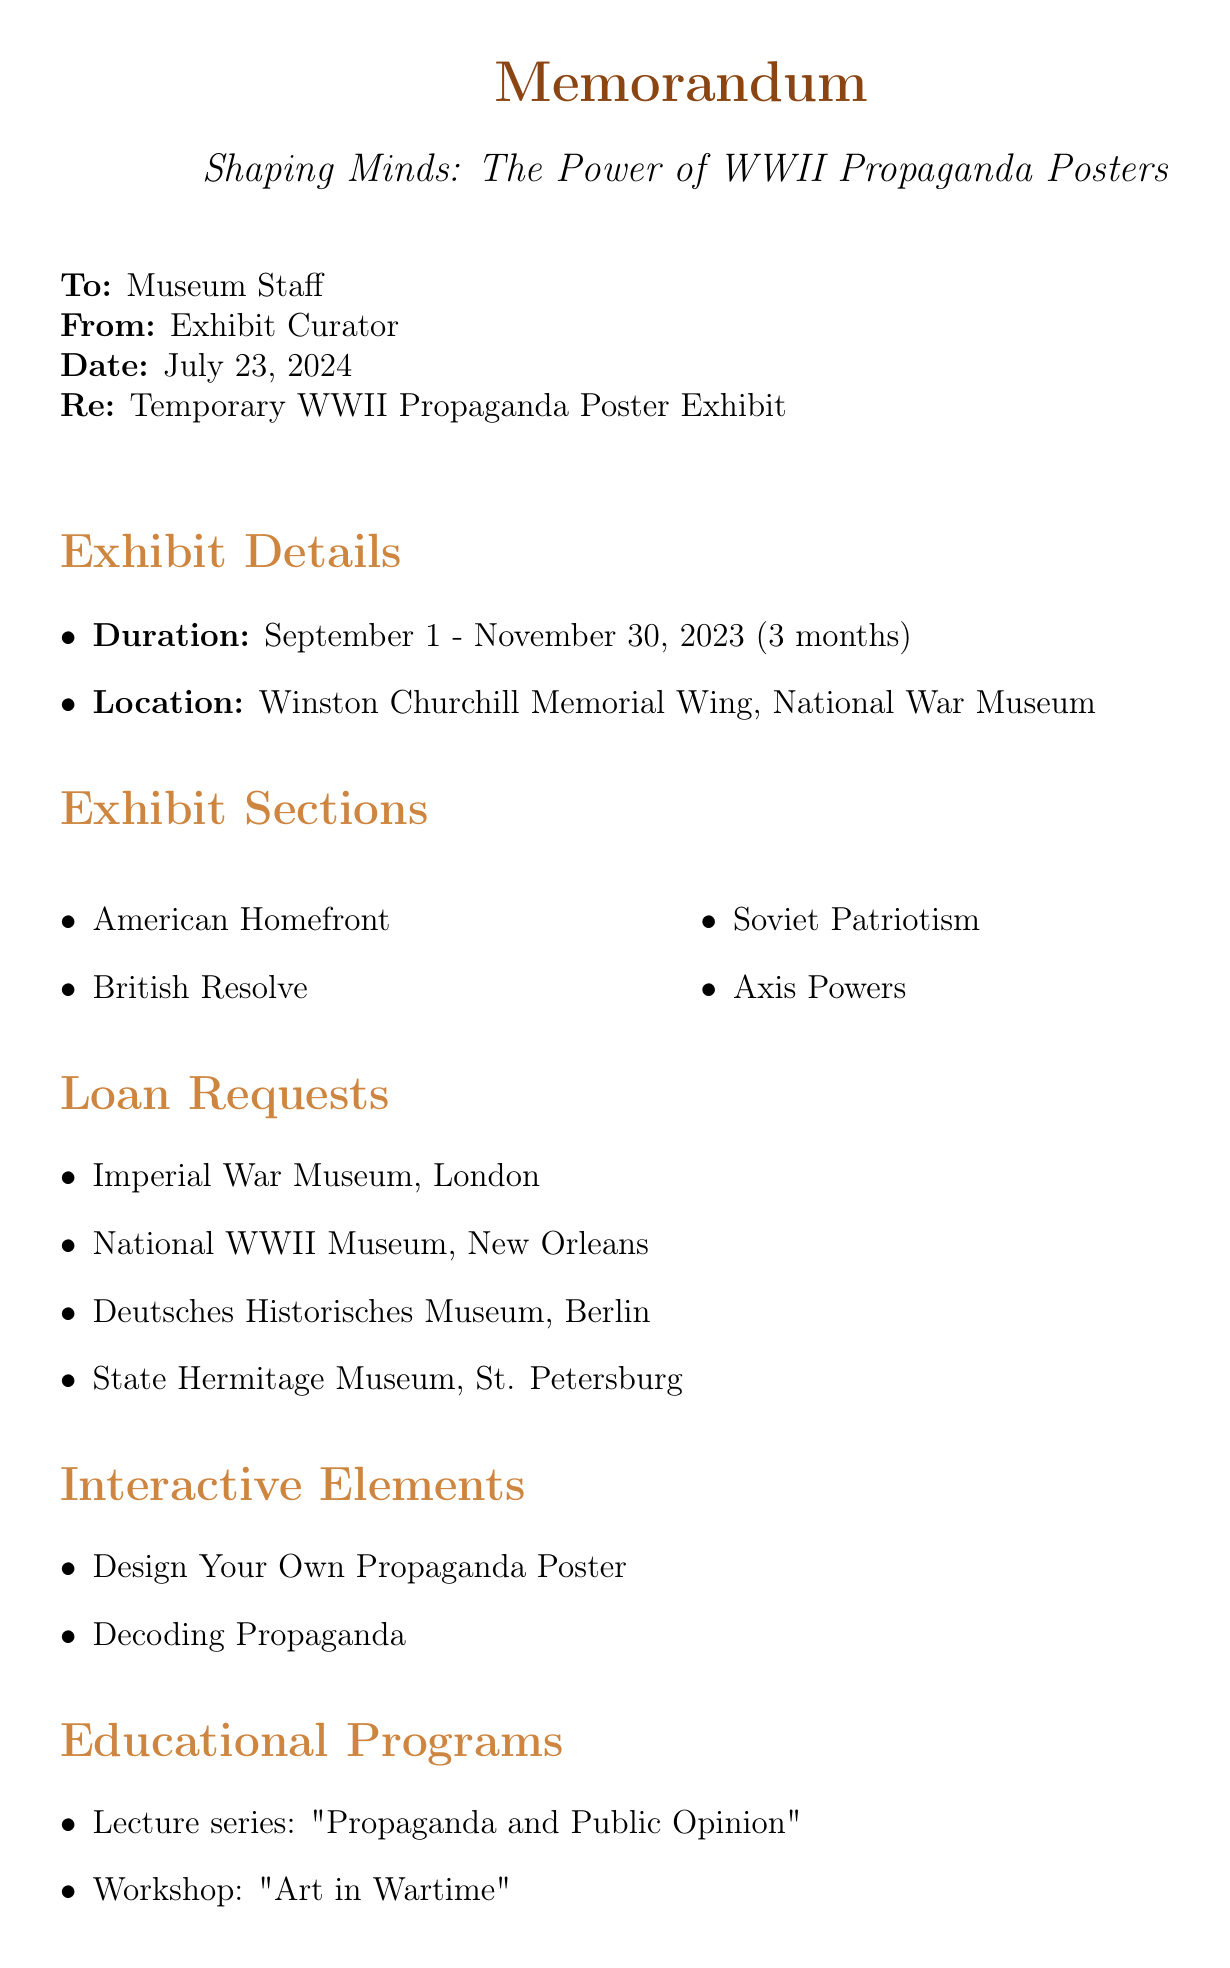What is the title of the exhibit? The title of the exhibit is stated at the beginning of the document.
Answer: Shaping Minds: The Power of WWII Propaganda Posters What is the duration of the exhibit? The duration is specified in the exhibit details.
Answer: 3 months (September 1 - November 30, 2023) Where will the exhibit be located? The location is mentioned under exhibit details.
Answer: Winston Churchill Memorial Wing, National War Museum Which institution is lending the 'We Can Do It!' poster? The loan requests section lists this information.
Answer: National WWII Museum, New Orleans Name one theme in the "Soviet Patriotism" section. Themes for each section are listed in the exhibit sections.
Answer: Mother Russia How much is allocated for educational programs? The budget allocation details the amount for educational programs.
Answer: $25,000 What type of interactive element allows visitors to create their own posters? The description of interactive elements specifies this feature.
Answer: Design Your Own Propaganda Poster Who is the instructor for the "Art in Wartime" workshop? The educational programs section provides the instructor's name.
Answer: Emily Chen How many sections are there in the exhibit? The number of sections can be deduced from the list in the exhibit sections.
Answer: 4 